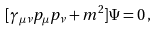<formula> <loc_0><loc_0><loc_500><loc_500>[ \gamma _ { \mu \nu } p _ { \mu } p _ { \nu } + m ^ { 2 } ] \Psi = 0 \, ,</formula> 